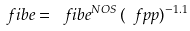<formula> <loc_0><loc_0><loc_500><loc_500>\ f i b e = \ f i b e ^ { N O S } \, ( \ f p p ) ^ { - 1 . 1 }</formula> 